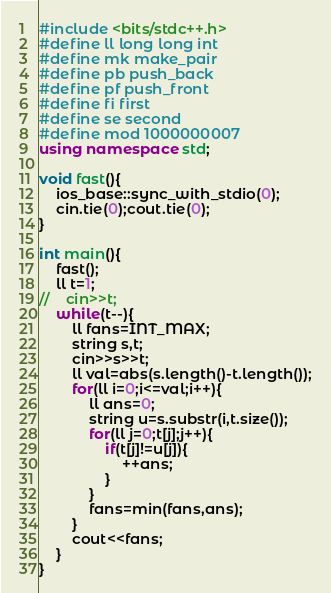Convert code to text. <code><loc_0><loc_0><loc_500><loc_500><_C++_>#include <bits/stdc++.h>
#define ll long long int
#define mk make_pair
#define pb push_back
#define pf push_front
#define fi first
#define se second
#define mod 1000000007
using namespace std;

void fast(){
    ios_base::sync_with_stdio(0);
    cin.tie(0);cout.tie(0);
}

int main(){
    fast();
    ll t=1;
//    cin>>t;
    while(t--){
    	ll fans=INT_MAX;
    	string s,t;
    	cin>>s>>t;
    	ll val=abs(s.length()-t.length());
    	for(ll i=0;i<=val;i++){
    		ll ans=0;
    		string u=s.substr(i,t.size());
    		for(ll j=0;t[j];j++){
    			if(t[j]!=u[j]){
    				++ans;
				}
			}
			fans=min(fans,ans);
		}
		cout<<fans;
	}
}</code> 